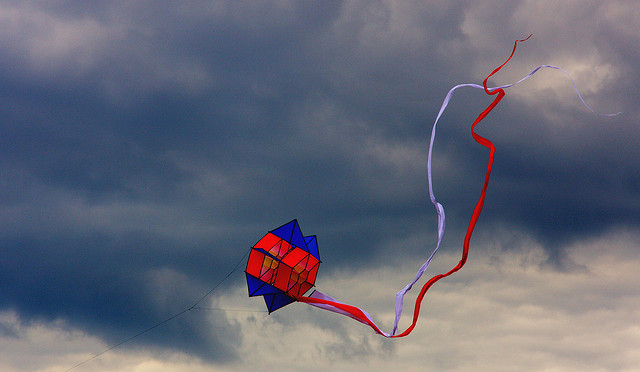What do you think the person flying this kite might be feeling? The person flying this kite might be experiencing a sense of freedom and joy. Flying a kite can be a relaxing and invigorating activity, offering a moment of connection with nature. The wind tugging at the string, guiding the colorful kite through the sky, might bring about a feeling of accomplishment and childlike wonder, especially against the dramatic backdrop of an overcast sky. Do you think there's a story behind the kite's design? It's highly likely that the kite's design holds a story. Perhaps the geometric pattern and vibrant colors are inspired by traditional cultural designs or personal significance for the person flying it. It could be a handmade creation, reflecting a connection or memory, a gift from a loved one, or a representation of personal freedom and creativity. The swirling tails might symbolize the flow of life, movement, and adventure. Imagine if this kite were a character in a story. What kind of personality would it have? If this kite were a character in a story, it would be a curious and adventurous spirit. With its vibrant colors and dynamic movement, it would embody a playful and determined personality, always eager to explore new heights and dance with the wind. It would have a sense of resilience, persistently soaring through storms and calm skies alike, a symbol of joy and freedom that inspires those who watch it. 